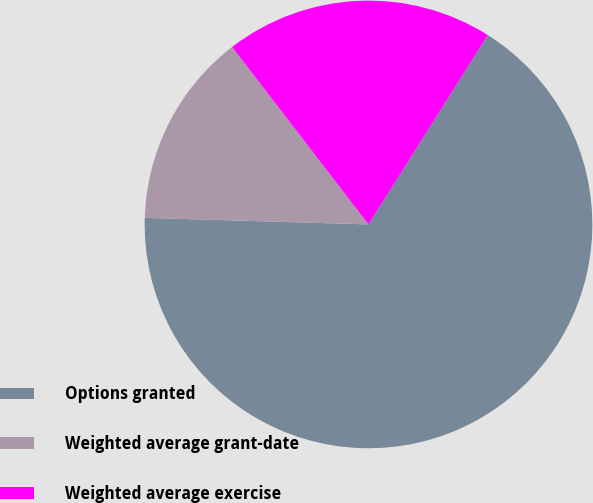<chart> <loc_0><loc_0><loc_500><loc_500><pie_chart><fcel>Options granted<fcel>Weighted average grant-date<fcel>Weighted average exercise<nl><fcel>66.52%<fcel>14.1%<fcel>19.38%<nl></chart> 